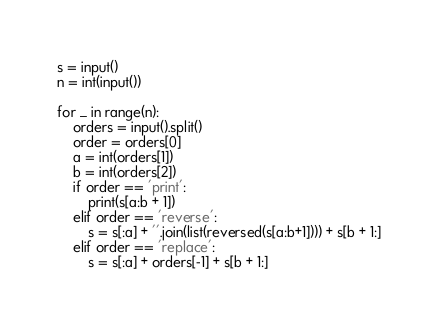Convert code to text. <code><loc_0><loc_0><loc_500><loc_500><_Python_>s = input()
n = int(input())

for _ in range(n):
    orders = input().split()
    order = orders[0]
    a = int(orders[1])
    b = int(orders[2])
    if order == 'print':
        print(s[a:b + 1])
    elif order == 'reverse':
        s = s[:a] + ''.join(list(reversed(s[a:b+1]))) + s[b + 1:]
    elif order == 'replace':
        s = s[:a] + orders[-1] + s[b + 1:]
</code> 